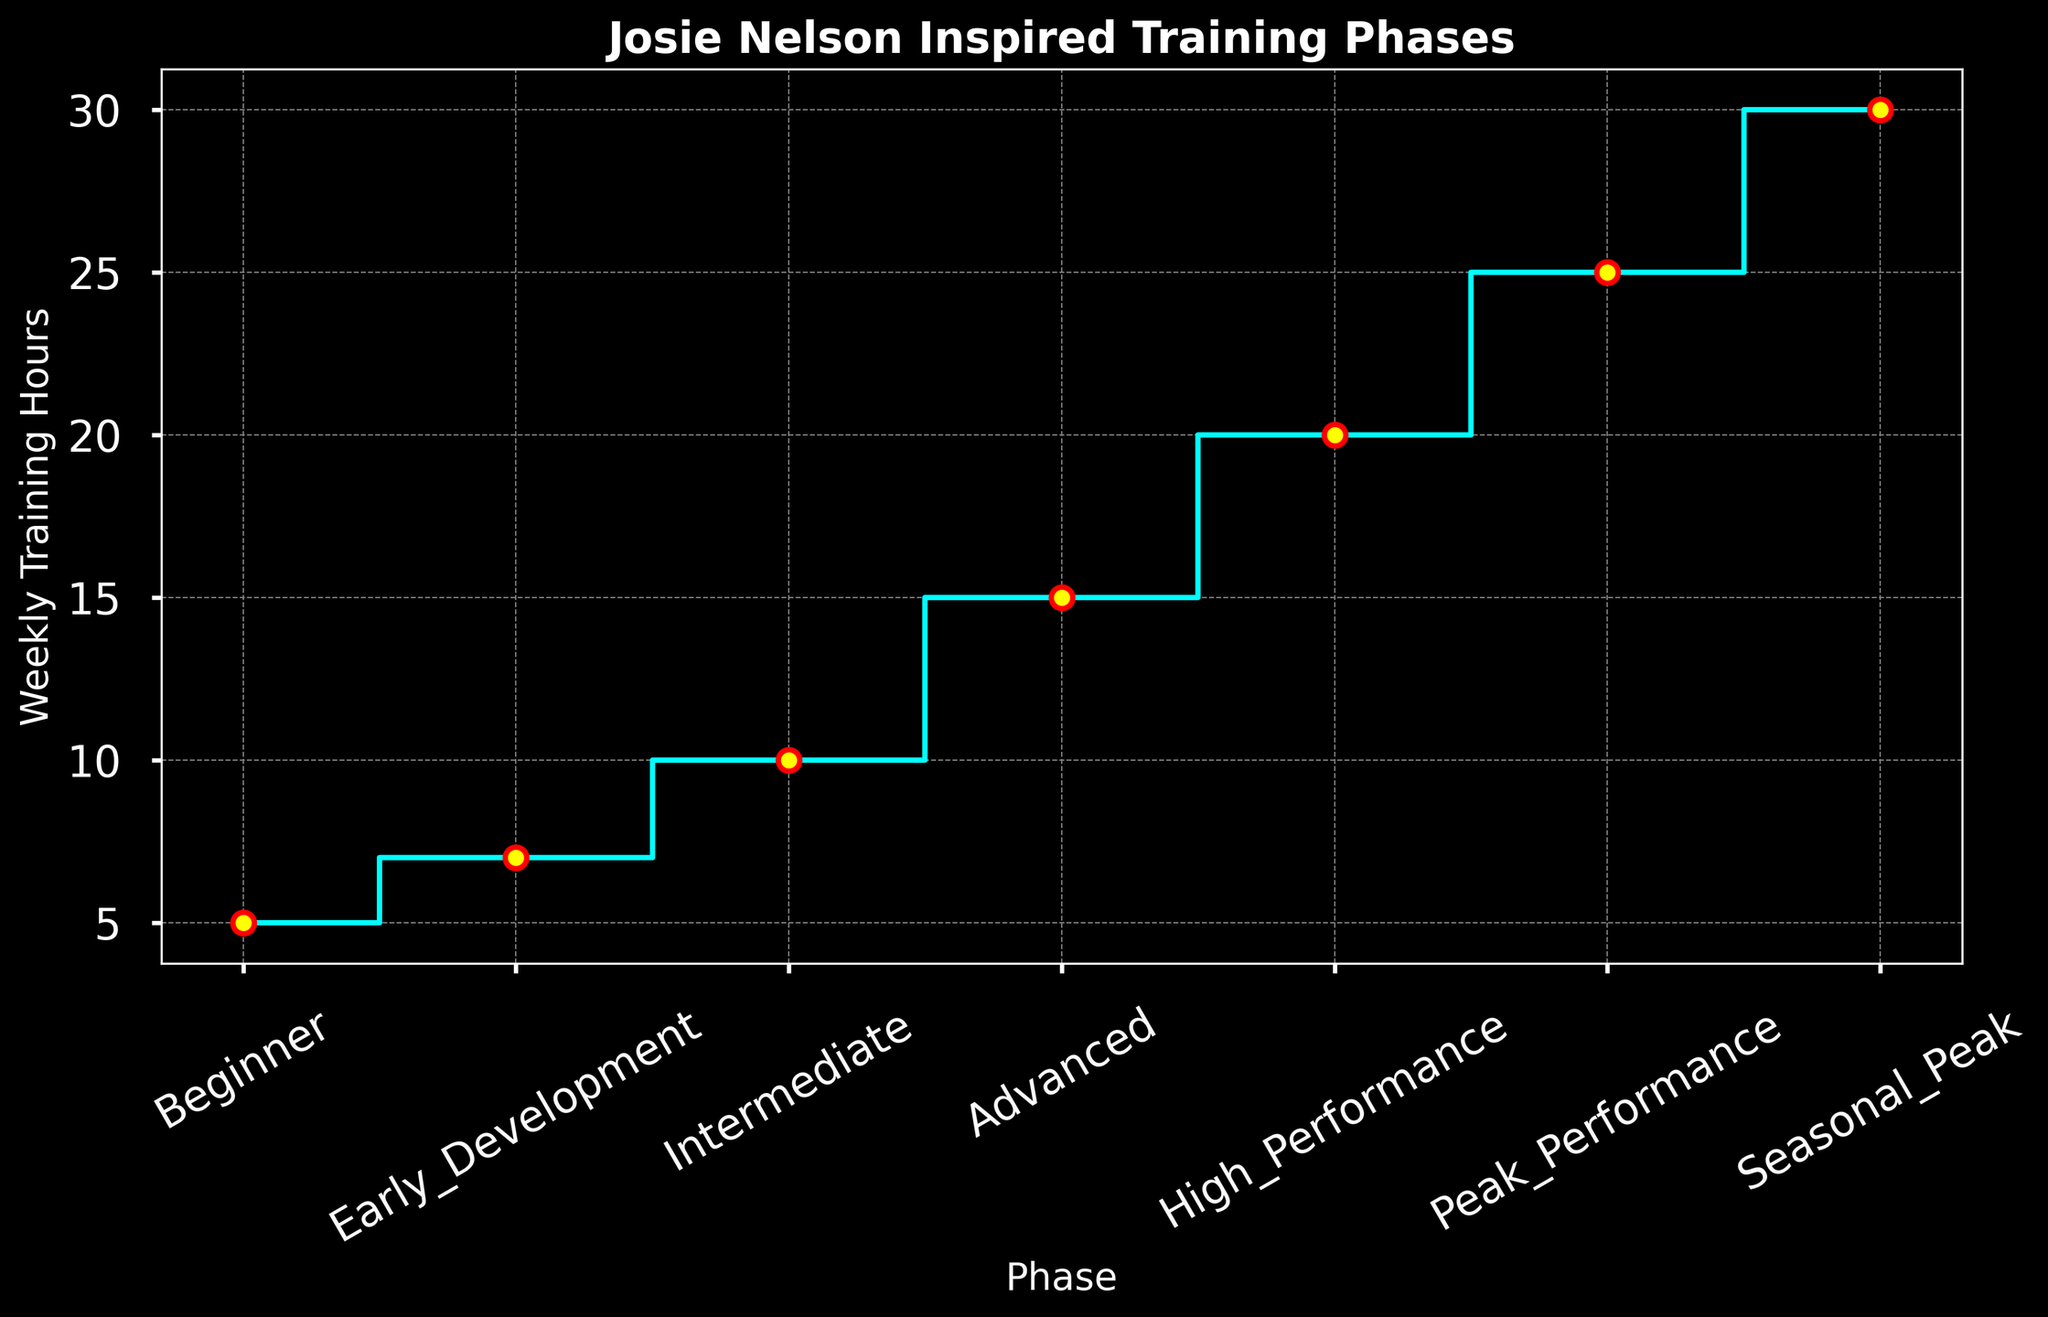What is the highest number of weekly training hours mentioned in the plot? Look at the highest point on the stairs plot. The peak value for weekly training hours is located at the "Seasonal Peak" phase.
Answer: 30 During which phase does the weekly training go from 15 to 20 hours? Identify the phase labels where the transition from 15 to 20 hours occurs. It starts with "Advanced" (15 hours) and goes to "High Performance" (20 hours).
Answer: High Performance What is the average weekly training hours during the "Beginner" and "Early Development" phases? Take the training hours for "Beginner" (5) and "Early Development" (7) and calculate the average. The calculation is (5 + 7) / 2 = 6.
Answer: 6 Which phase shows the greatest increase in weekly training hours compared to the previous phase? Evaluate the difference in weekly training hours between consecutive phases. The largest increase occurs between "Peak Performance" (25) and "Seasonal Peak" (30).
Answer: Seasonal Peak By how many hours do the weekly training hours increase from "Beginner" to "Advanced" phase? Calculate the difference in training hours from "Beginner" (5) to "Advanced" (15). The increase is 15 - 5 = 10.
Answer: 10 What is the total weekly training hours for phases from "Intermediate" to "Peak Performance"? Add up the training hours for "Intermediate" (10), "Advanced" (15), "High Performance" (20), and "Peak Performance" (25). The sum is 10 + 15 + 20 + 25 = 70.
Answer: 70 Which phase has the least number of weekly training hours? Identify the lowest point on the stairs plot, which corresponds to the "Beginner" phase with 5 weekly training hours.
Answer: Beginner What is the color of the markers used in the plot? Observe the plot and identify the color of the markers used at each data point. The markers are yellow.
Answer: Yellow Does the weekly training hours increase or decrease consistently across all phases? Check the progression of values in the stairs plot. The weekly training hours increase consistently through each phase.
Answer: Increase consistently What is the average weekly training hours from "Beginner" to "Intermediate" phase? Calculate the average for the phases "Beginner" (5), "Early Development" (7), and "Intermediate" (10). The calculation is (5 + 7 + 10) / 3 = 7.33 (rounded to two decimal places).
Answer: 7.33 